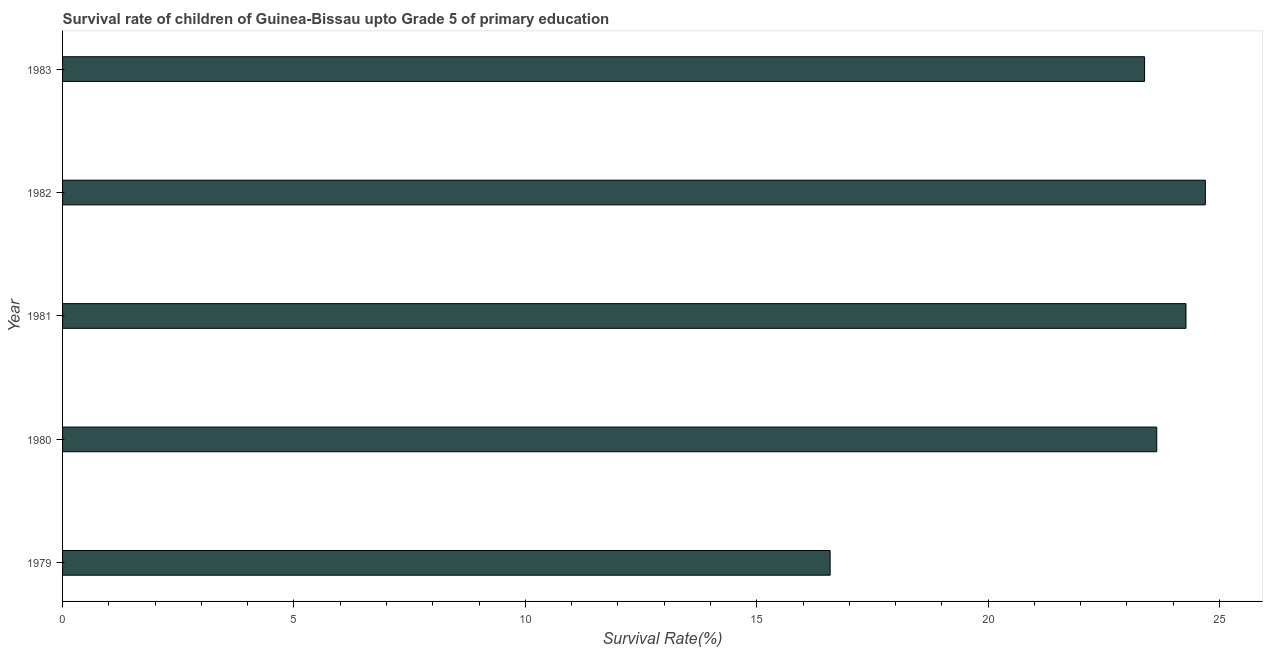Does the graph contain any zero values?
Give a very brief answer. No. Does the graph contain grids?
Your answer should be very brief. No. What is the title of the graph?
Offer a very short reply. Survival rate of children of Guinea-Bissau upto Grade 5 of primary education. What is the label or title of the X-axis?
Offer a very short reply. Survival Rate(%). What is the survival rate in 1980?
Give a very brief answer. 23.64. Across all years, what is the maximum survival rate?
Provide a short and direct response. 24.69. Across all years, what is the minimum survival rate?
Your response must be concise. 16.59. In which year was the survival rate minimum?
Keep it short and to the point. 1979. What is the sum of the survival rate?
Offer a very short reply. 112.58. What is the difference between the survival rate in 1981 and 1982?
Provide a succinct answer. -0.42. What is the average survival rate per year?
Your response must be concise. 22.52. What is the median survival rate?
Keep it short and to the point. 23.64. Do a majority of the years between 1983 and 1981 (inclusive) have survival rate greater than 18 %?
Your response must be concise. Yes. Is the difference between the survival rate in 1981 and 1982 greater than the difference between any two years?
Make the answer very short. No. What is the difference between the highest and the second highest survival rate?
Your answer should be very brief. 0.42. What is the difference between the highest and the lowest survival rate?
Offer a terse response. 8.11. In how many years, is the survival rate greater than the average survival rate taken over all years?
Keep it short and to the point. 4. How many bars are there?
Your response must be concise. 5. How many years are there in the graph?
Your answer should be compact. 5. What is the difference between two consecutive major ticks on the X-axis?
Keep it short and to the point. 5. Are the values on the major ticks of X-axis written in scientific E-notation?
Give a very brief answer. No. What is the Survival Rate(%) of 1979?
Your answer should be compact. 16.59. What is the Survival Rate(%) of 1980?
Keep it short and to the point. 23.64. What is the Survival Rate(%) of 1981?
Give a very brief answer. 24.28. What is the Survival Rate(%) of 1982?
Give a very brief answer. 24.69. What is the Survival Rate(%) in 1983?
Give a very brief answer. 23.38. What is the difference between the Survival Rate(%) in 1979 and 1980?
Provide a succinct answer. -7.06. What is the difference between the Survival Rate(%) in 1979 and 1981?
Offer a terse response. -7.69. What is the difference between the Survival Rate(%) in 1979 and 1982?
Give a very brief answer. -8.11. What is the difference between the Survival Rate(%) in 1979 and 1983?
Provide a succinct answer. -6.79. What is the difference between the Survival Rate(%) in 1980 and 1981?
Your answer should be compact. -0.63. What is the difference between the Survival Rate(%) in 1980 and 1982?
Ensure brevity in your answer.  -1.05. What is the difference between the Survival Rate(%) in 1980 and 1983?
Keep it short and to the point. 0.26. What is the difference between the Survival Rate(%) in 1981 and 1982?
Provide a short and direct response. -0.42. What is the difference between the Survival Rate(%) in 1981 and 1983?
Offer a terse response. 0.89. What is the difference between the Survival Rate(%) in 1982 and 1983?
Your answer should be very brief. 1.31. What is the ratio of the Survival Rate(%) in 1979 to that in 1980?
Provide a short and direct response. 0.7. What is the ratio of the Survival Rate(%) in 1979 to that in 1981?
Offer a terse response. 0.68. What is the ratio of the Survival Rate(%) in 1979 to that in 1982?
Offer a very short reply. 0.67. What is the ratio of the Survival Rate(%) in 1979 to that in 1983?
Your answer should be compact. 0.71. What is the ratio of the Survival Rate(%) in 1980 to that in 1981?
Your answer should be very brief. 0.97. What is the ratio of the Survival Rate(%) in 1980 to that in 1982?
Your answer should be very brief. 0.96. What is the ratio of the Survival Rate(%) in 1981 to that in 1983?
Your response must be concise. 1.04. What is the ratio of the Survival Rate(%) in 1982 to that in 1983?
Keep it short and to the point. 1.06. 